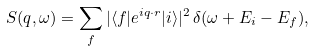<formula> <loc_0><loc_0><loc_500><loc_500>S ( { q } , \omega ) = \sum _ { f } | \langle f | e ^ { i { q } \cdot { r } } | i \rangle | ^ { 2 } \, \delta ( \omega + E _ { i } - E _ { f } ) ,</formula> 